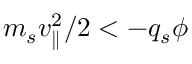Convert formula to latex. <formula><loc_0><loc_0><loc_500><loc_500>m _ { s } v _ { \| } ^ { 2 } / 2 < - q _ { s } \phi</formula> 